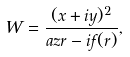Convert formula to latex. <formula><loc_0><loc_0><loc_500><loc_500>W = \frac { ( x + i y ) ^ { 2 } } { a z r - i f ( r ) } ,</formula> 